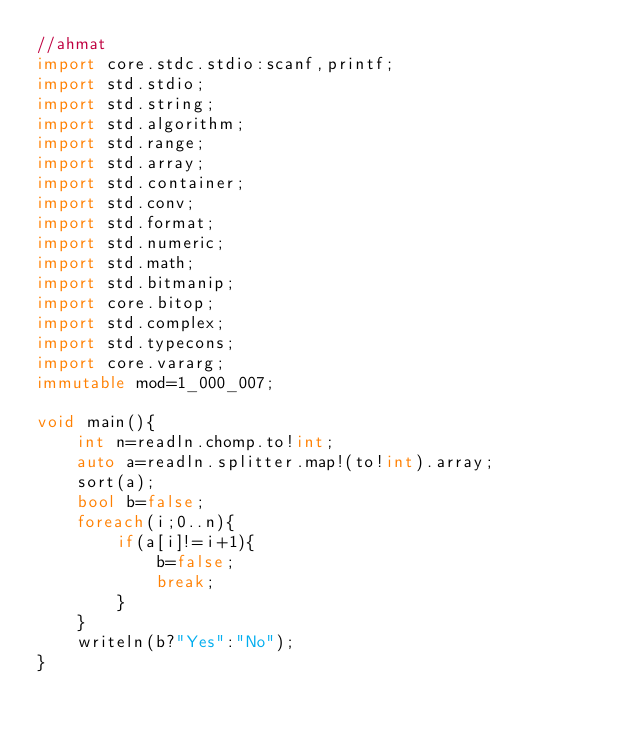<code> <loc_0><loc_0><loc_500><loc_500><_D_>//ahmat
import core.stdc.stdio:scanf,printf;
import std.stdio;
import std.string;
import std.algorithm;
import std.range;
import std.array;
import std.container;
import std.conv;
import std.format;
import std.numeric;
import std.math;
import std.bitmanip;
import core.bitop;
import std.complex;
import std.typecons;
import core.vararg;
immutable mod=1_000_007;

void main(){
    int n=readln.chomp.to!int;
    auto a=readln.splitter.map!(to!int).array;
    sort(a);
    bool b=false;
    foreach(i;0..n){
        if(a[i]!=i+1){
            b=false;
            break;
        }
    }
    writeln(b?"Yes":"No");
}
</code> 